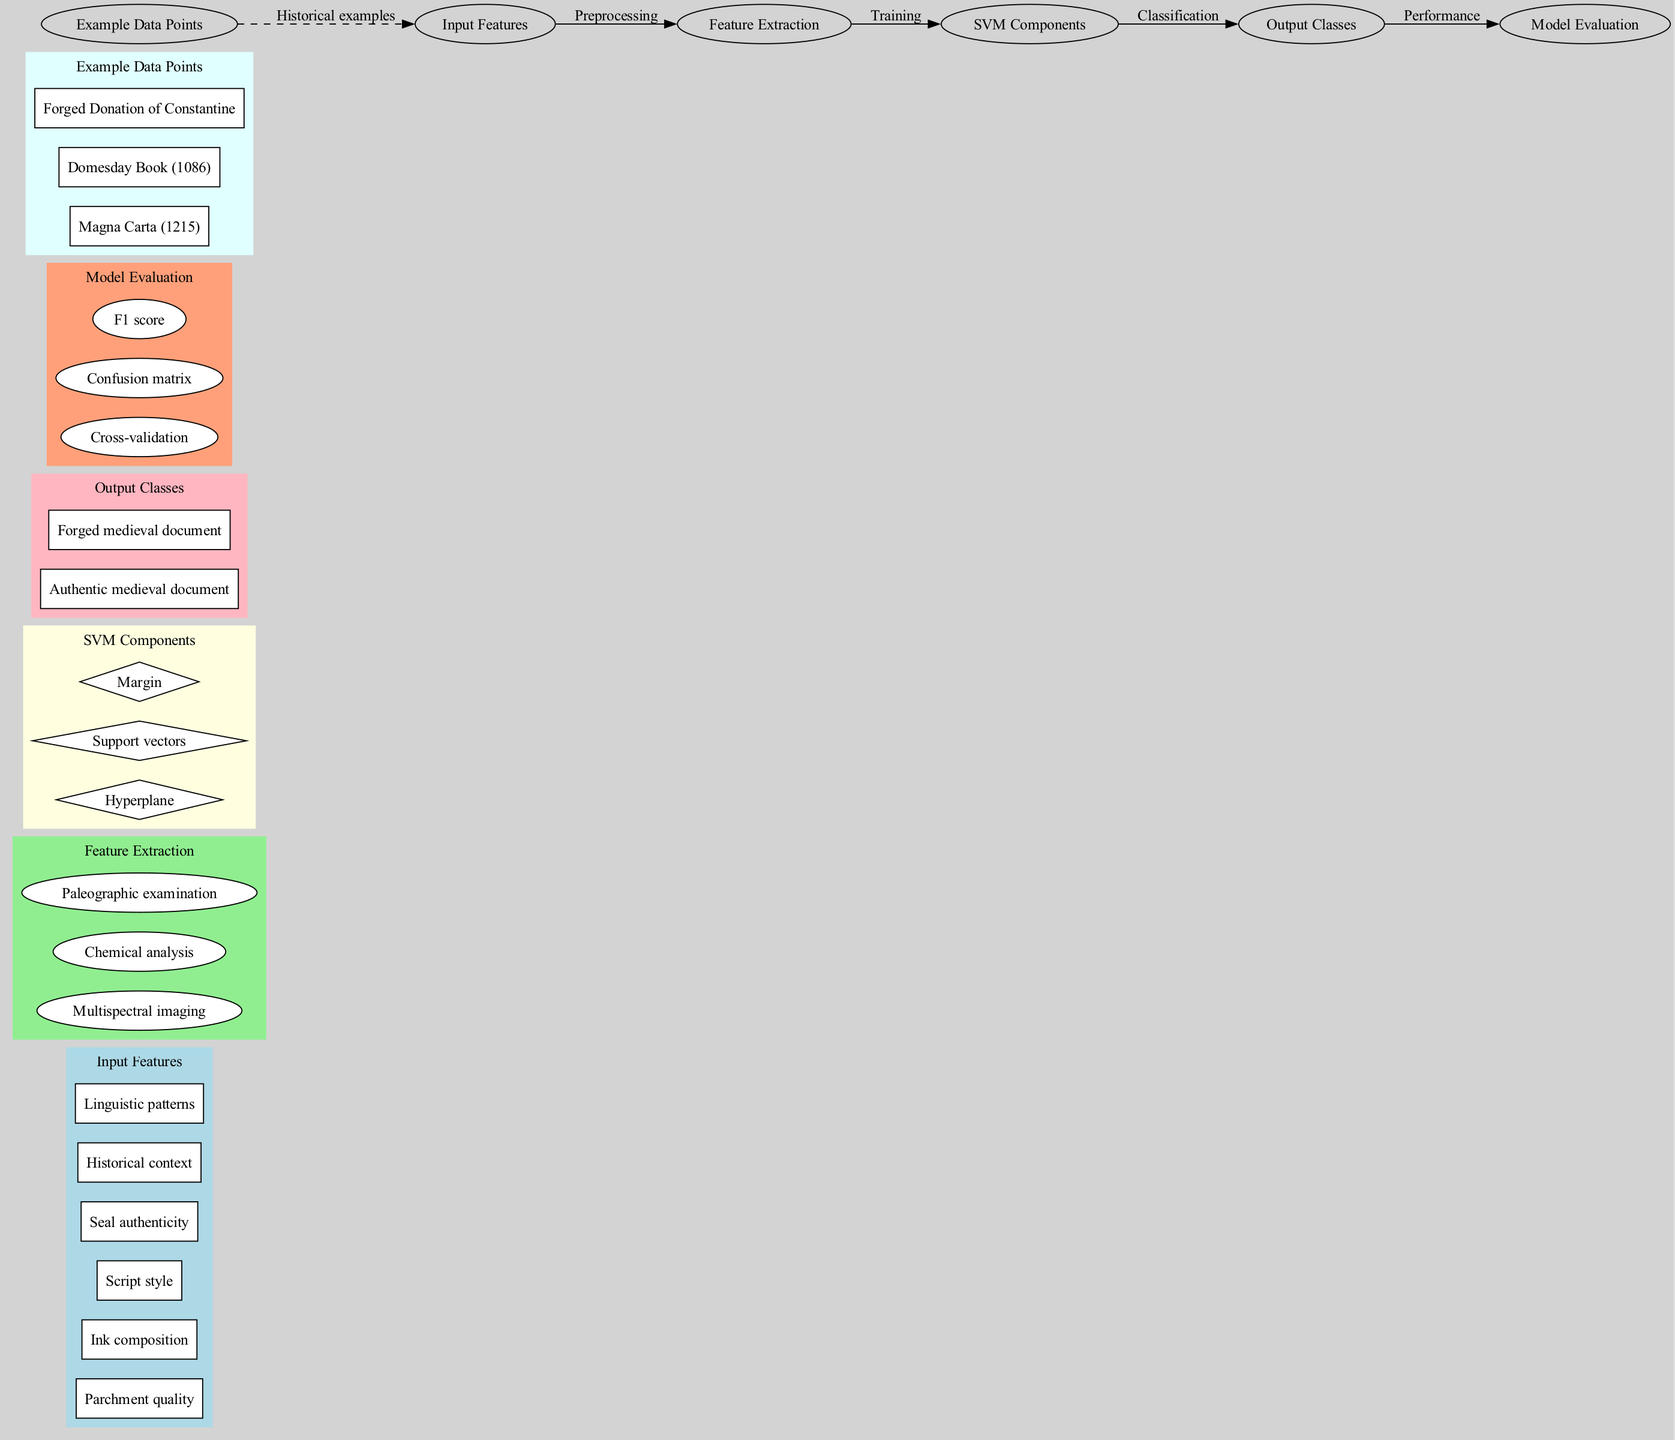What are the input features listed in the diagram? The input features are categorized in a subgraph labeled "Input Features," and the specific features mentioned include Parchment quality, Ink composition, Script style, Seal authenticity, Historical context, and Linguistic patterns.
Answer: Parchment quality, Ink composition, Script style, Seal authenticity, Historical context, Linguistic patterns How many SVM components are there in the diagram? The SVM components are shown in the "SVM Components" subgraph, which contains three nodes: Hyperplane, Support vectors, and Margin. Counting these nodes gives a total of 3 components.
Answer: 3 Which feature extraction methods are used in the process? The feature extraction methods are displayed in the "Feature Extraction" subgraph, including Multispectral imaging, Chemical analysis, and Paleographic examination. The answer comprises the names of these methods.
Answer: Multispectral imaging, Chemical analysis, Paleographic examination What connects the Output Classes to the Model Evaluation? In the diagram, there is an edge labeled "Performance" that connects the node for Output Classes to the node for Model Evaluation, indicating that the performance of the classification is assessed based on the output classes.
Answer: Performance What is the relationship between Example Data Points and Input Features? The relationship is represented by a dashed edge labeled "Historical examples," linking the Example Data Points to the Input Features, signifying that the historical documents serve as examples for the input features studied.
Answer: Historical examples What is the first step in the process illustrated in the diagram? The first step in the process involves the Input Features, which are the initial elements fed into the workflow leading to feature extraction and subsequent steps. This can be identified by tracing the flow from left to right, where Input Features are the starting point.
Answer: Input Features Which data point is an example of a forged medieval document? Among the listed data points in the "Example Data Points" subgraph, "Forged Donation of Constantine" is identified as the example of a forged medieval document.
Answer: Forged Donation of Constantine How are model evaluation methods categorized in the diagram? The model evaluation methods, such as Cross-validation, Confusion matrix, and F1 score, are organized within their own subgraph labeled "Model Evaluation," indicating a specific focus on assessing the performance of the SVM model.
Answer: Model Evaluation What is the purpose of the Hyperplane in SVM components? The Hyperplane serves as a decision boundary in the SVM components, differentiating between the two output classes: Authentic medieval document and Forged medieval document. This role can be inferred from the positioning of the Hyperplane node within the context of SVM classification.
Answer: Decision boundary 